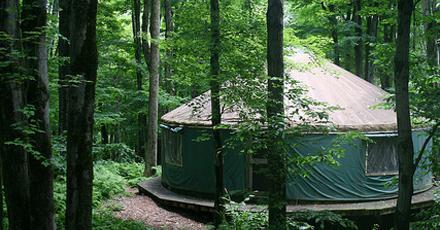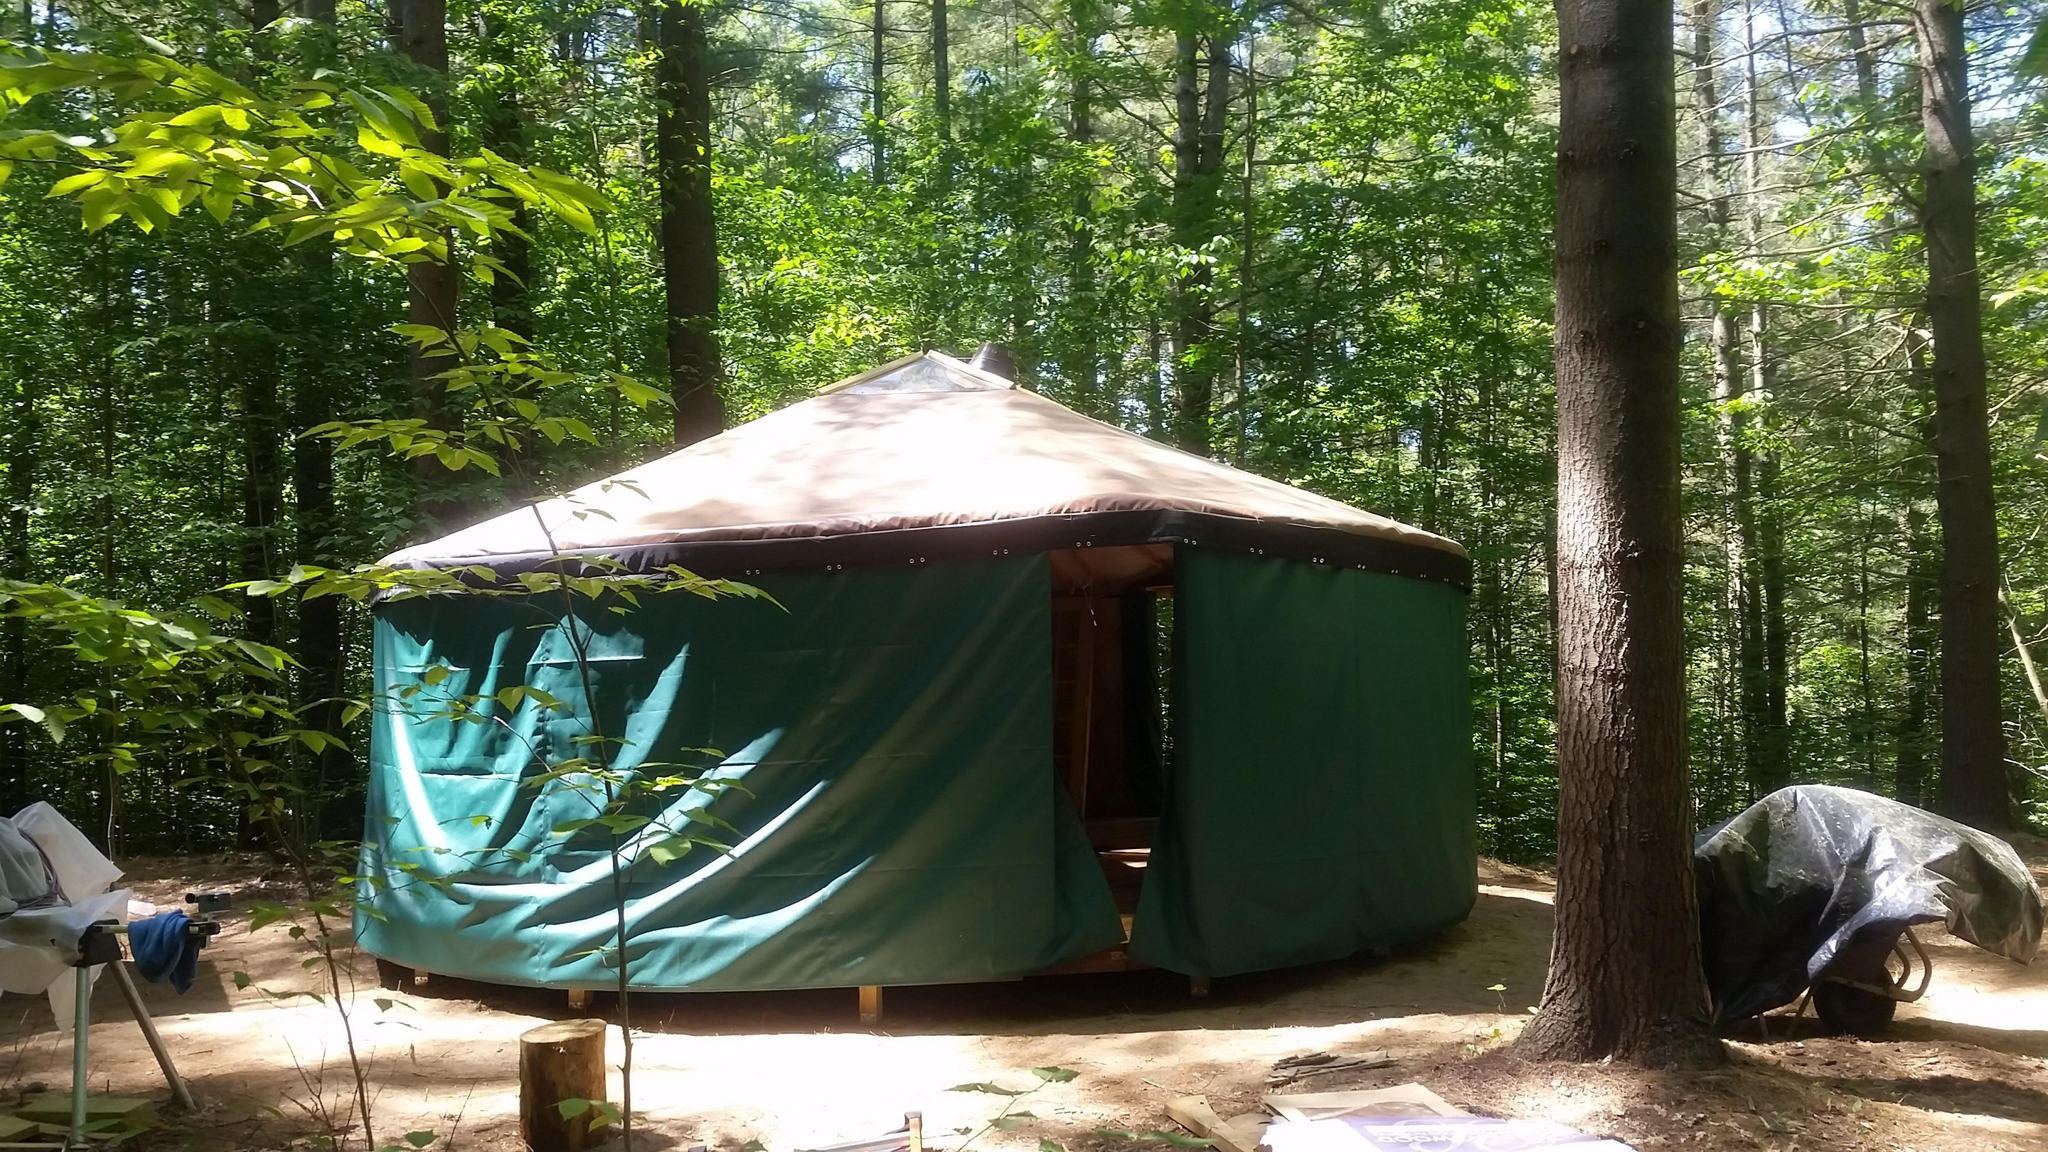The first image is the image on the left, the second image is the image on the right. Considering the images on both sides, is "Two round houses are dark teal green with light colored conical roofs." valid? Answer yes or no. Yes. The first image is the image on the left, the second image is the image on the right. For the images displayed, is the sentence "At least one image shows a circular home with green exterior 'walls'." factually correct? Answer yes or no. Yes. 